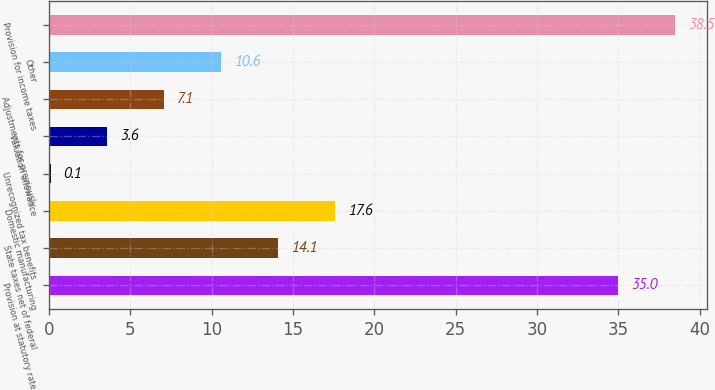<chart> <loc_0><loc_0><loc_500><loc_500><bar_chart><fcel>Provision at statutory rate<fcel>State taxes net of federal<fcel>Domestic manufacturing<fcel>Unrecognized tax benefits<fcel>Valuation allowance<fcel>Adjustments for previously<fcel>Other<fcel>Provision for income taxes<nl><fcel>35<fcel>14.1<fcel>17.6<fcel>0.1<fcel>3.6<fcel>7.1<fcel>10.6<fcel>38.5<nl></chart> 